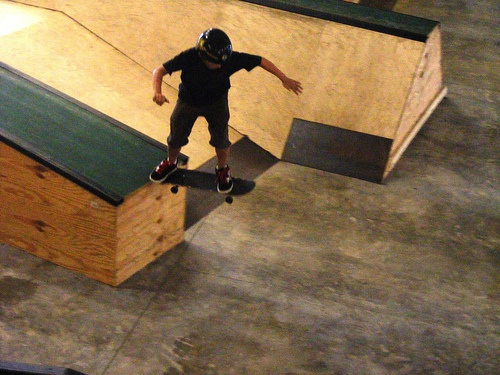Describe the objects in this image and their specific colors. I can see people in tan, black, maroon, and brown tones and skateboard in tan, black, maroon, and olive tones in this image. 